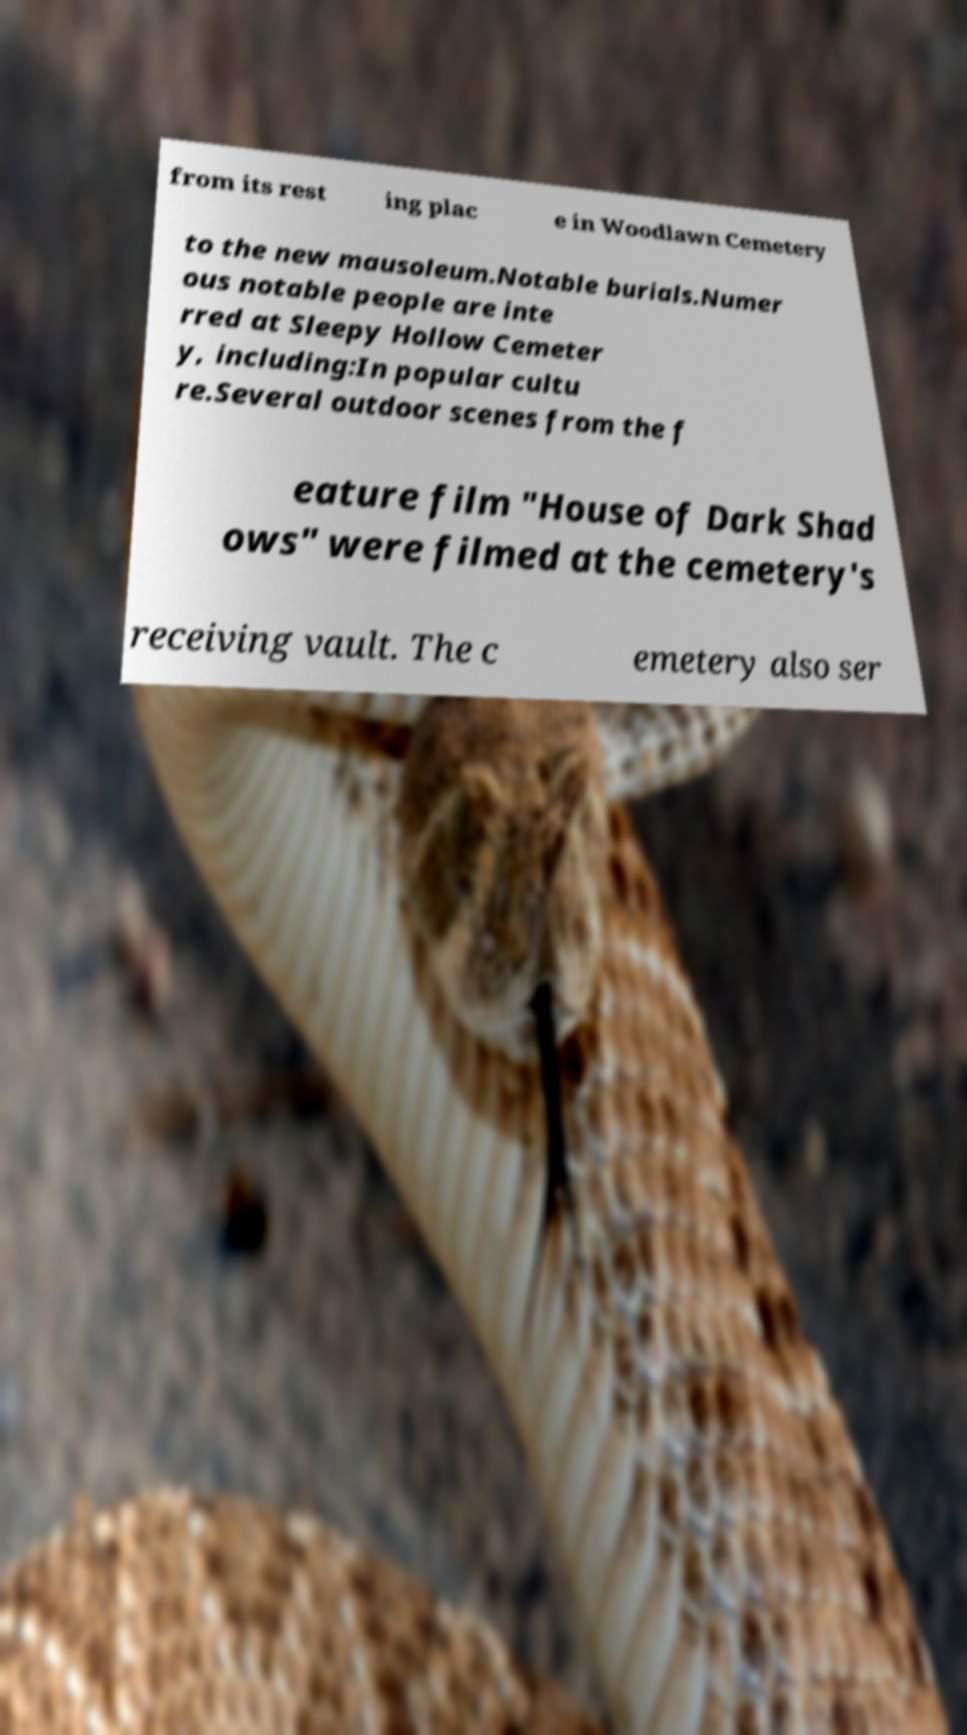Please read and relay the text visible in this image. What does it say? from its rest ing plac e in Woodlawn Cemetery to the new mausoleum.Notable burials.Numer ous notable people are inte rred at Sleepy Hollow Cemeter y, including:In popular cultu re.Several outdoor scenes from the f eature film "House of Dark Shad ows" were filmed at the cemetery's receiving vault. The c emetery also ser 